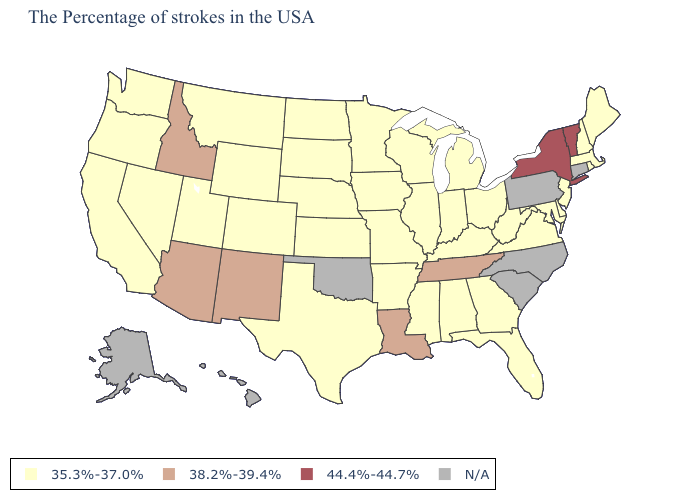Name the states that have a value in the range N/A?
Give a very brief answer. Connecticut, Pennsylvania, North Carolina, South Carolina, Oklahoma, Alaska, Hawaii. Name the states that have a value in the range 44.4%-44.7%?
Concise answer only. Vermont, New York. What is the value of Connecticut?
Answer briefly. N/A. Does the first symbol in the legend represent the smallest category?
Be succinct. Yes. Which states have the lowest value in the West?
Give a very brief answer. Wyoming, Colorado, Utah, Montana, Nevada, California, Washington, Oregon. What is the value of Michigan?
Write a very short answer. 35.3%-37.0%. Which states have the lowest value in the Northeast?
Quick response, please. Maine, Massachusetts, Rhode Island, New Hampshire, New Jersey. What is the highest value in states that border West Virginia?
Give a very brief answer. 35.3%-37.0%. Does Kentucky have the lowest value in the South?
Quick response, please. Yes. What is the value of Georgia?
Concise answer only. 35.3%-37.0%. What is the value of Rhode Island?
Concise answer only. 35.3%-37.0%. What is the lowest value in the MidWest?
Concise answer only. 35.3%-37.0%. Does the map have missing data?
Short answer required. Yes. Name the states that have a value in the range N/A?
Answer briefly. Connecticut, Pennsylvania, North Carolina, South Carolina, Oklahoma, Alaska, Hawaii. Among the states that border Georgia , does Alabama have the lowest value?
Write a very short answer. Yes. 